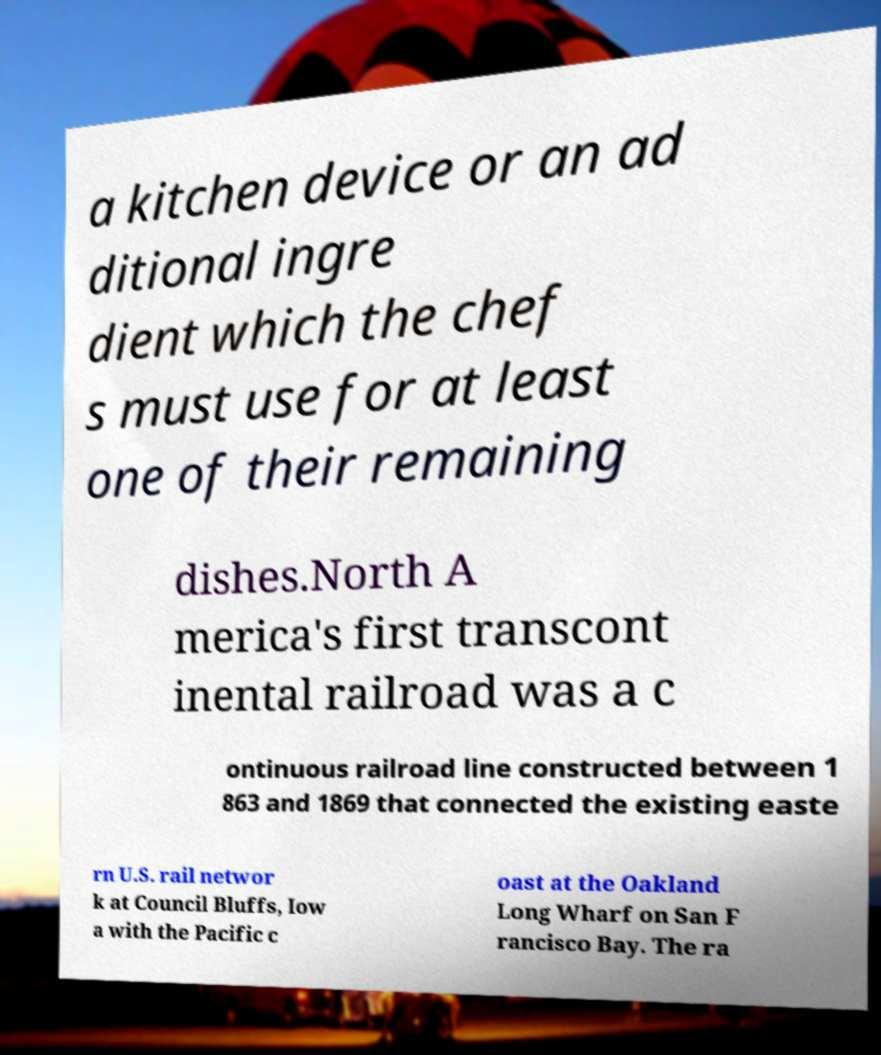Please identify and transcribe the text found in this image. a kitchen device or an ad ditional ingre dient which the chef s must use for at least one of their remaining dishes.North A merica's first transcont inental railroad was a c ontinuous railroad line constructed between 1 863 and 1869 that connected the existing easte rn U.S. rail networ k at Council Bluffs, Iow a with the Pacific c oast at the Oakland Long Wharf on San F rancisco Bay. The ra 